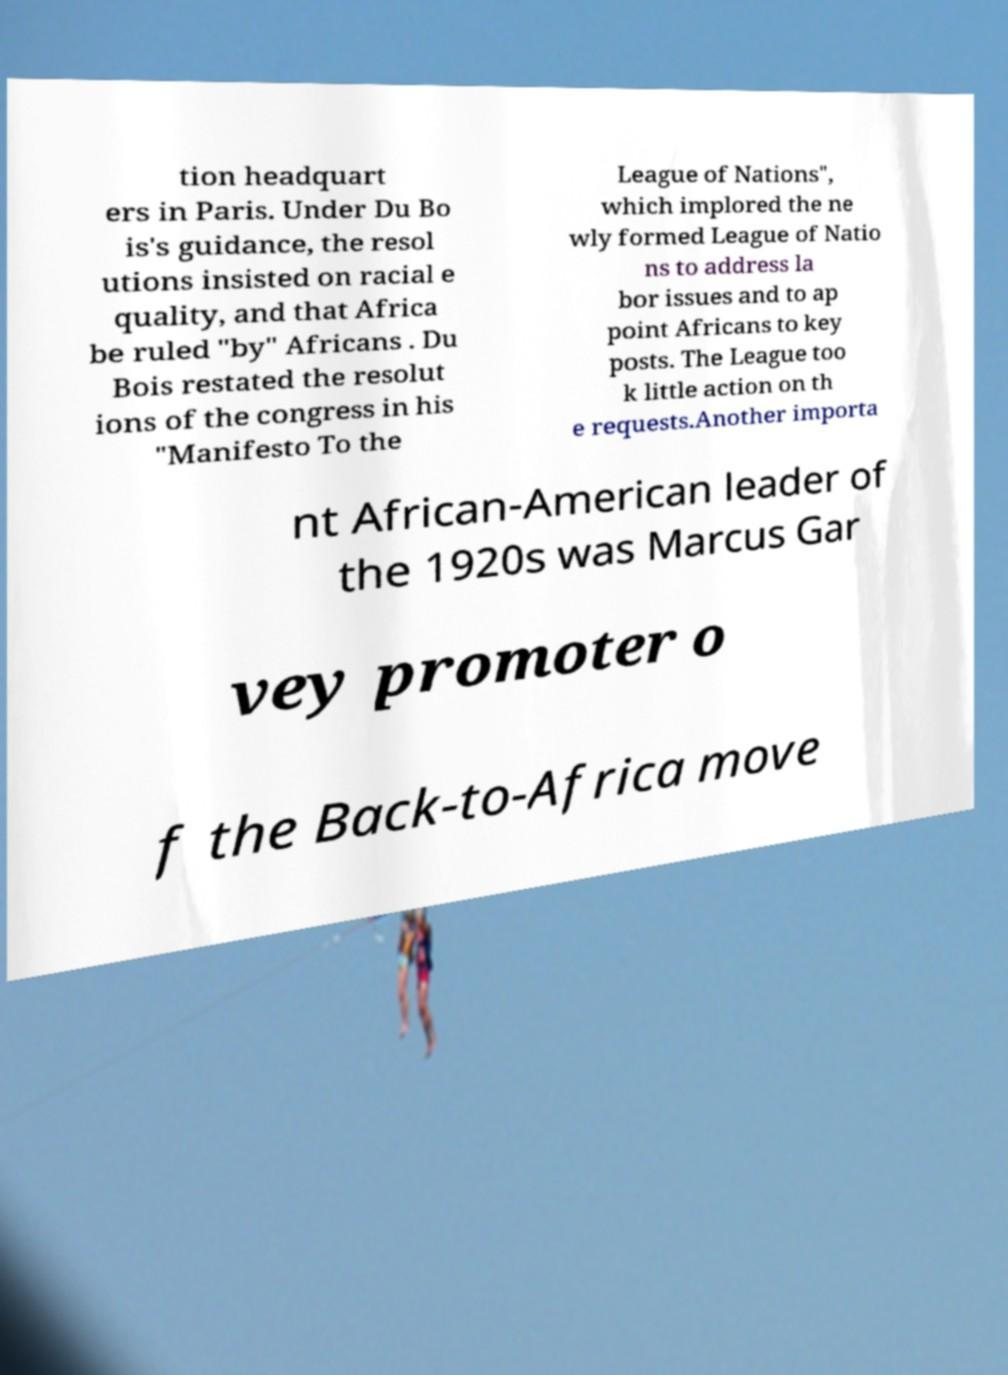What messages or text are displayed in this image? I need them in a readable, typed format. tion headquart ers in Paris. Under Du Bo is's guidance, the resol utions insisted on racial e quality, and that Africa be ruled "by" Africans . Du Bois restated the resolut ions of the congress in his "Manifesto To the League of Nations", which implored the ne wly formed League of Natio ns to address la bor issues and to ap point Africans to key posts. The League too k little action on th e requests.Another importa nt African-American leader of the 1920s was Marcus Gar vey promoter o f the Back-to-Africa move 